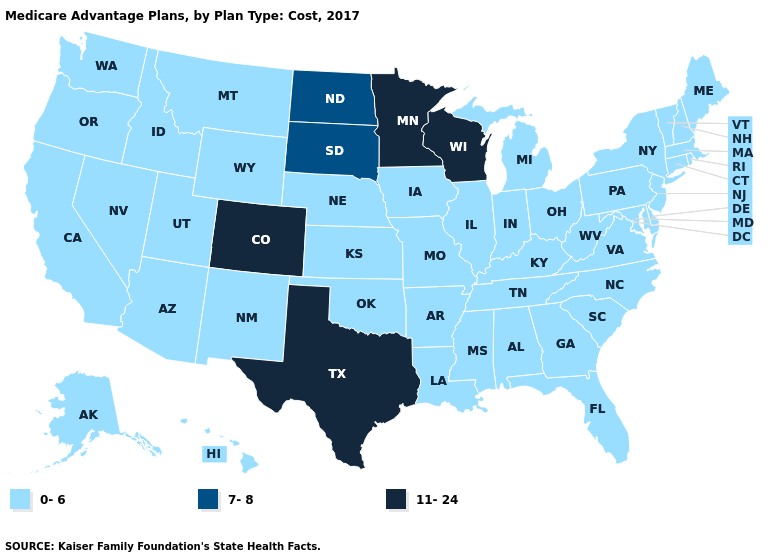Does the map have missing data?
Keep it brief. No. What is the value of Utah?
Quick response, please. 0-6. What is the highest value in the USA?
Write a very short answer. 11-24. Does Mississippi have the lowest value in the South?
Answer briefly. Yes. What is the value of New Mexico?
Short answer required. 0-6. What is the value of Georgia?
Concise answer only. 0-6. Does Missouri have a lower value than Texas?
Short answer required. Yes. What is the value of Pennsylvania?
Write a very short answer. 0-6. Does the map have missing data?
Quick response, please. No. Among the states that border Arizona , which have the lowest value?
Write a very short answer. California, New Mexico, Nevada, Utah. What is the lowest value in the USA?
Quick response, please. 0-6. Which states have the lowest value in the USA?
Be succinct. Alaska, Alabama, Arkansas, Arizona, California, Connecticut, Delaware, Florida, Georgia, Hawaii, Iowa, Idaho, Illinois, Indiana, Kansas, Kentucky, Louisiana, Massachusetts, Maryland, Maine, Michigan, Missouri, Mississippi, Montana, North Carolina, Nebraska, New Hampshire, New Jersey, New Mexico, Nevada, New York, Ohio, Oklahoma, Oregon, Pennsylvania, Rhode Island, South Carolina, Tennessee, Utah, Virginia, Vermont, Washington, West Virginia, Wyoming. Does the first symbol in the legend represent the smallest category?
Be succinct. Yes. Name the states that have a value in the range 11-24?
Be succinct. Colorado, Minnesota, Texas, Wisconsin. Is the legend a continuous bar?
Short answer required. No. 